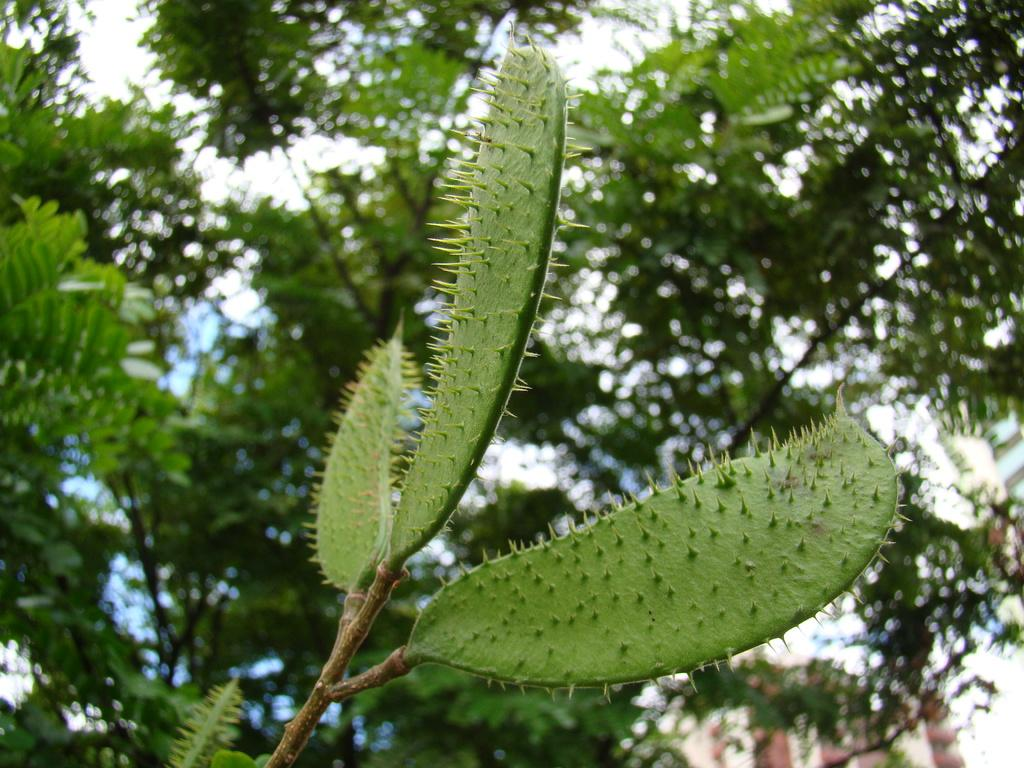What type of plant is in the center of the image? There is a plant with thorns in the center of the image. What can be seen in the background of the image? There is a tree in the background of the image. How many times did the plant kick the ball in the image? There is no ball or kicking action present in the image; it features a plant with thorns and a tree in the background. 